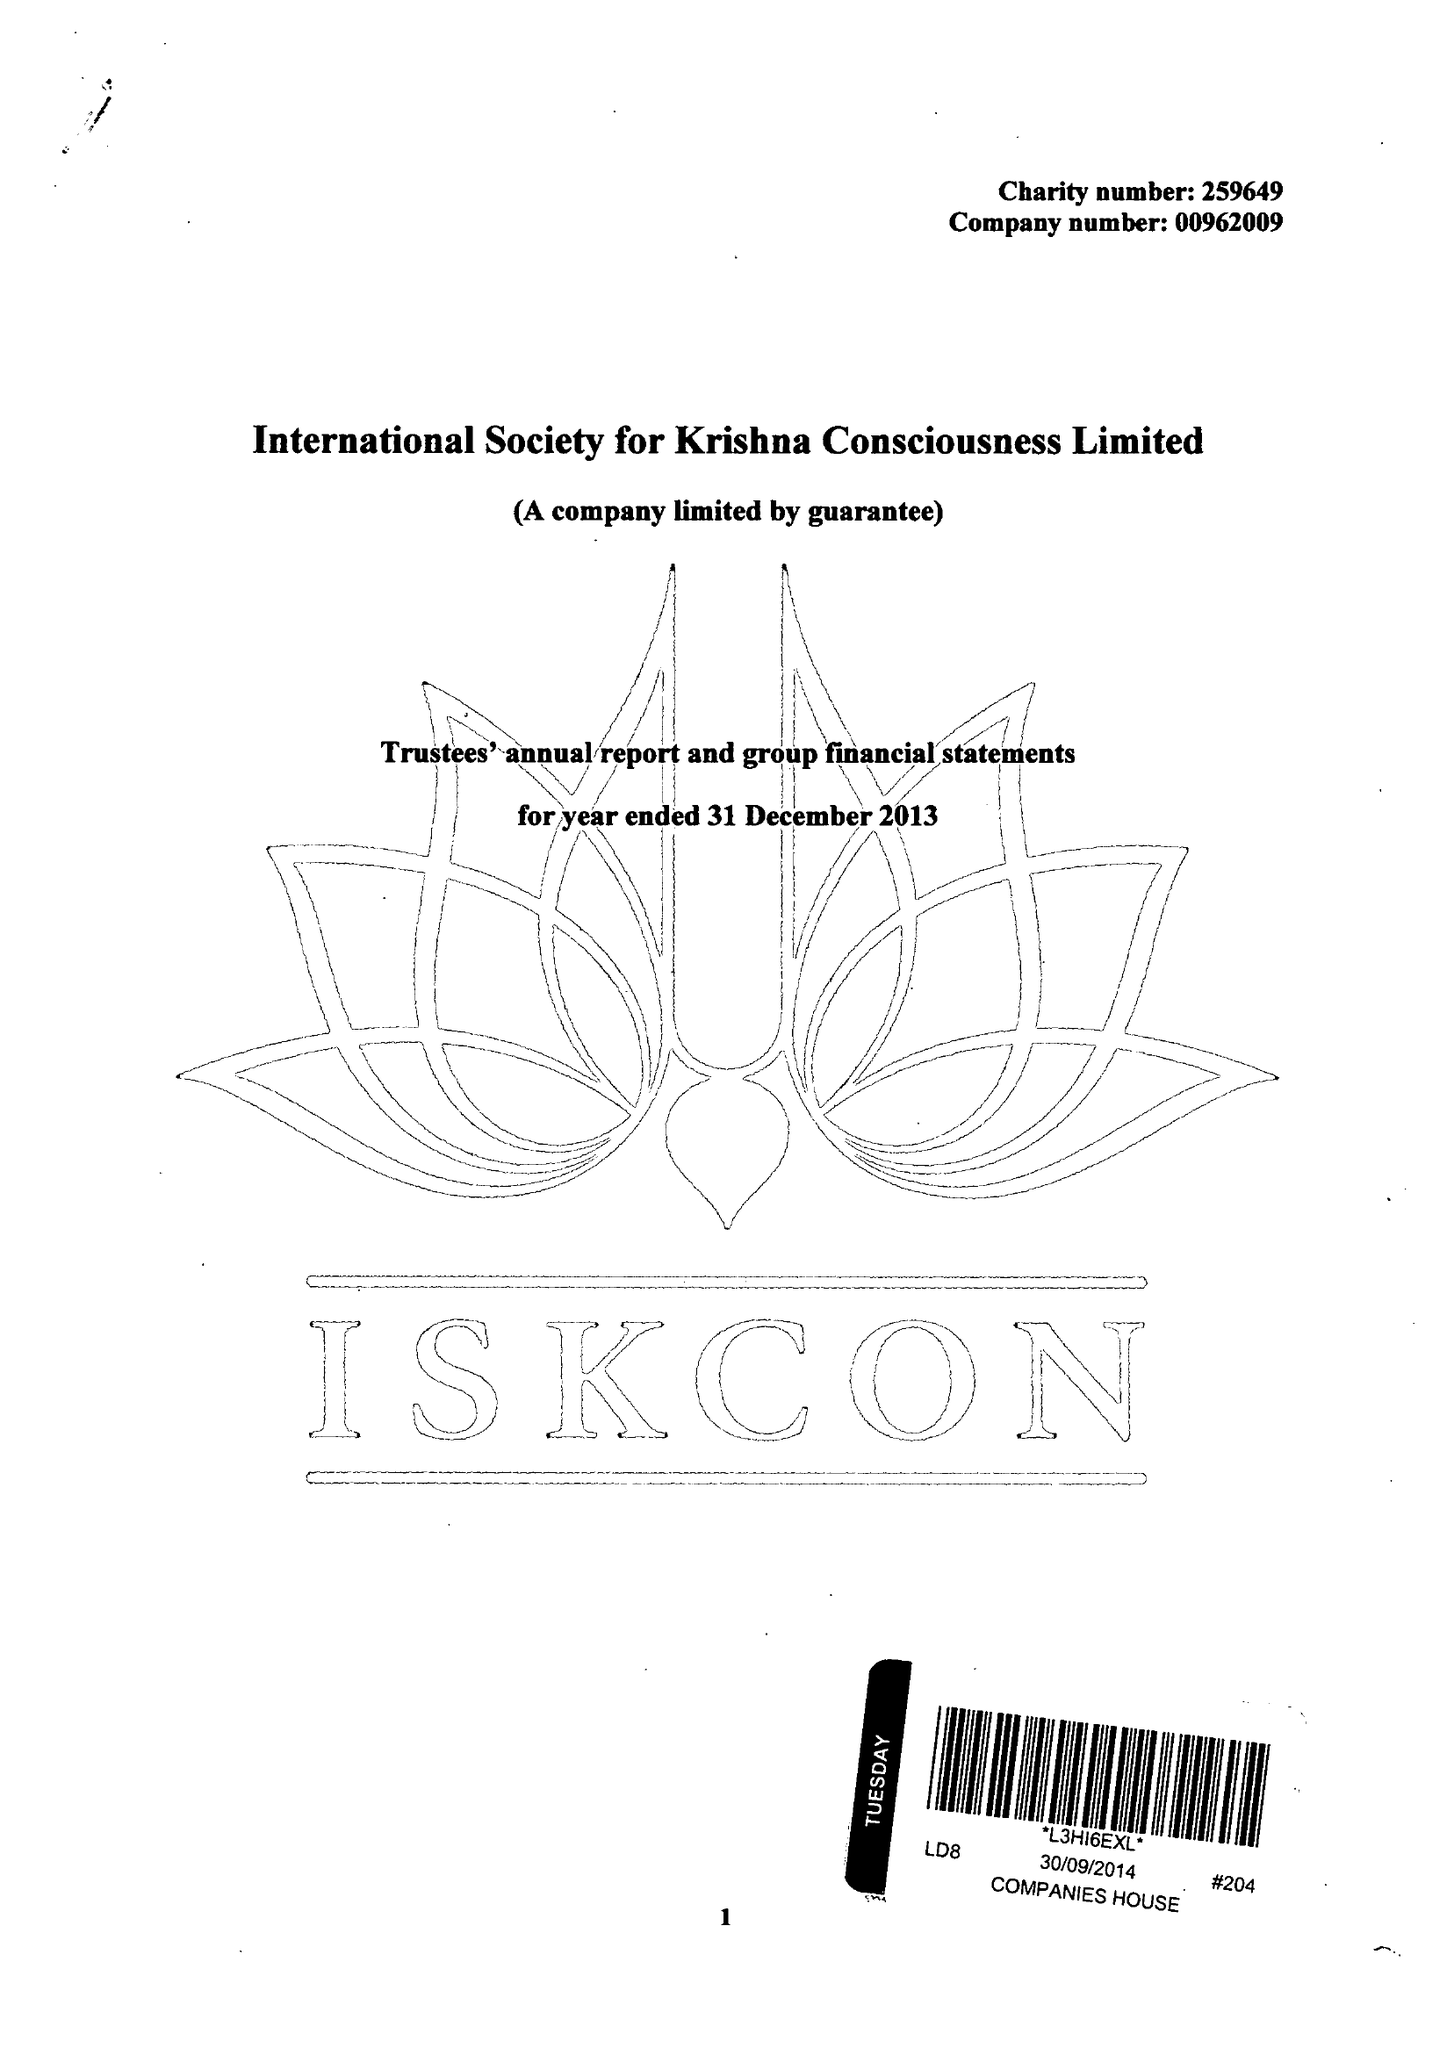What is the value for the charity_number?
Answer the question using a single word or phrase. 259649 